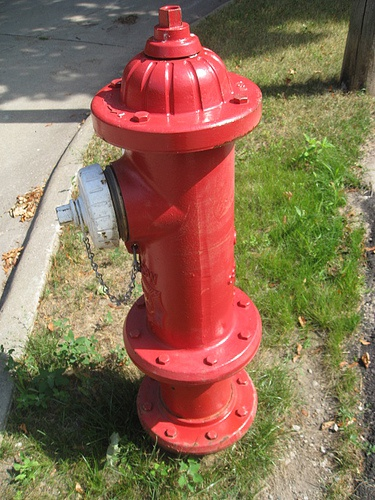Describe the objects in this image and their specific colors. I can see a fire hydrant in black, salmon, maroon, and brown tones in this image. 